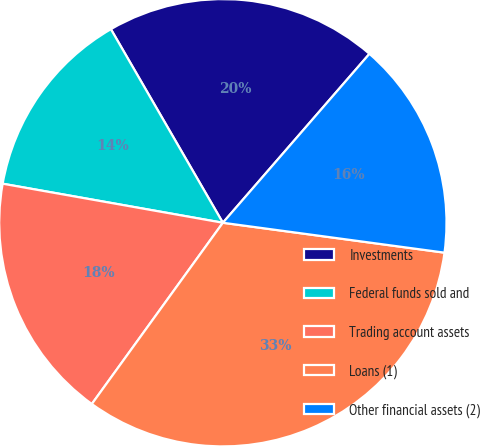Convert chart to OTSL. <chart><loc_0><loc_0><loc_500><loc_500><pie_chart><fcel>Investments<fcel>Federal funds sold and<fcel>Trading account assets<fcel>Loans (1)<fcel>Other financial assets (2)<nl><fcel>19.72%<fcel>13.86%<fcel>17.83%<fcel>32.83%<fcel>15.76%<nl></chart> 